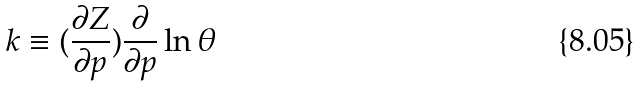Convert formula to latex. <formula><loc_0><loc_0><loc_500><loc_500>k \equiv ( \frac { \partial Z } { \partial p } ) \frac { \partial } { \partial p } \ln \theta</formula> 